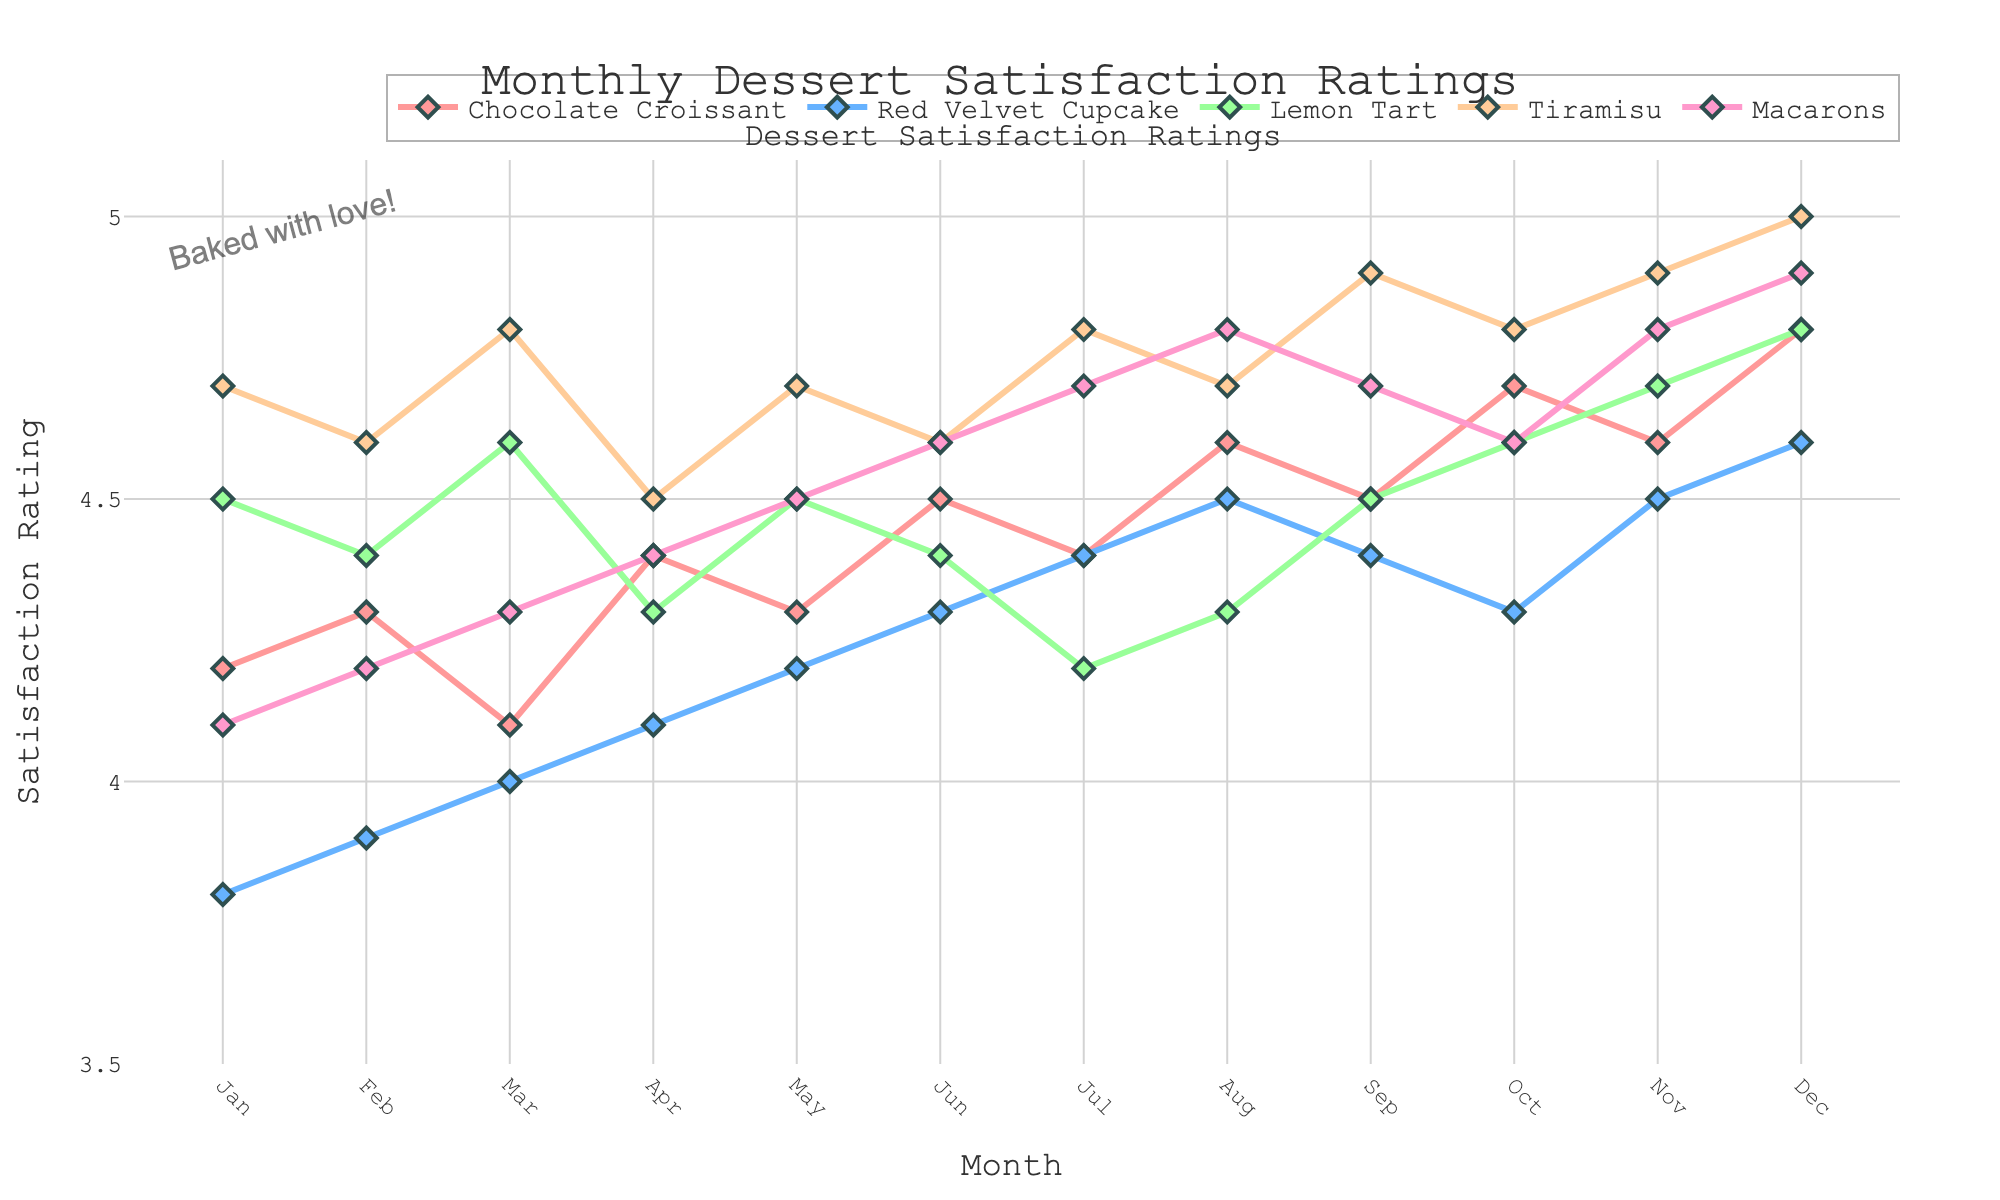What's the highest satisfaction rating in December and which dessert does it correspond to? Look at the December data point and identify the highest rating. In December, the highest rating is 5.0 for Tiramisu.
Answer: Tiramisu with 5.0 How did the satisfaction rating for Lemon Tart change from January to December? Subtract the January rating of Lemon Tart (4.5) from the December rating (4.8). The change is 4.8 - 4.5 = 0.3.
Answer: Increased by 0.3 Which dessert had the most steady increase in satisfaction rating over the months? Compare the trends of each line. Macarons show a consistent increase each month without any dips.
Answer: Macarons What's the average satisfaction rating for Red Velvet Cupcake over the year? Add all monthly ratings (3.8 + 3.9 + 4.0 + 4.1 + 4.2 + 4.3 + 4.4 + 4.5 + 4.4 + 4.3 + 4.5 + 4.6) and divide by 12. The average is (4.1 + 3.9 + 4.0 + 4.1 + 4.2 + 4.3 + 4.4 + 4.5 + 4.4 + 4.3 + 4.5 + 4.6) / 12 ≈ 4.28.
Answer: 4.28 Which month has the lowest average satisfaction rating across all desserts? Calculate the average for each month and find the lowest. January's average is (4.2 + 3.8 + 4.5 + 4.7 + 4.1) / 5 = 21.3 / 5 ≈ 4.26, February's average is (4.3 + 3.9 + 4.4 + 4.6 + 4.2) / 5 ≈ 4.28, etc. The lowest is in January (≈ 4.26).
Answer: January What is the difference in satisfaction ratings between Chocolate Croissant and Macarons in November? Subtract the November rating of Macarons from Chocolate Croissant. The difference is 4.6 - 4.8 = -0.2.
Answer: -0.2 Which dessert has the most variation in satisfaction ratings over the months? Look at the range of ratings for each dessert and identify the largest. Red Velvet Cupcake ranges from 3.8 to 4.6, which is the widest variation of 0.8.
Answer: Red Velvet Cupcake Did any dessert achieve a perfect score over the year? Check if any dessert reached a 5.0 rating in any month. Tiramisu reached 5.0 in December.
Answer: Yes, Tiramisu in December In which month did Tiramisu reach its first peak rating of 4.9? Look for the first instance of Tiramisu reaching the 4.9 rating. Tiramisu first reached 4.9 in September.
Answer: September 